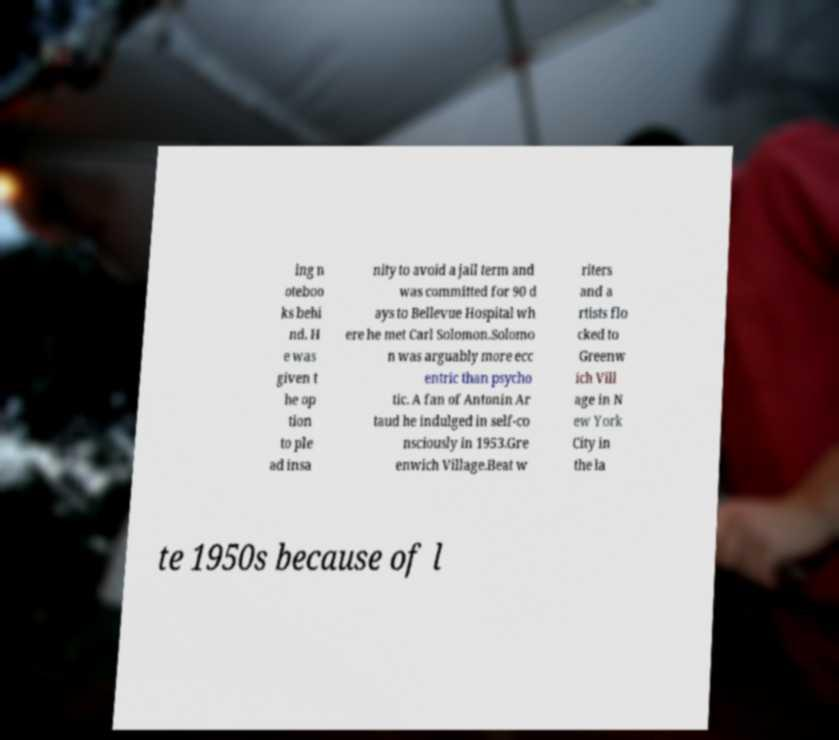There's text embedded in this image that I need extracted. Can you transcribe it verbatim? ing n oteboo ks behi nd. H e was given t he op tion to ple ad insa nity to avoid a jail term and was committed for 90 d ays to Bellevue Hospital wh ere he met Carl Solomon.Solomo n was arguably more ecc entric than psycho tic. A fan of Antonin Ar taud he indulged in self-co nsciously in 1953.Gre enwich Village.Beat w riters and a rtists flo cked to Greenw ich Vill age in N ew York City in the la te 1950s because of l 